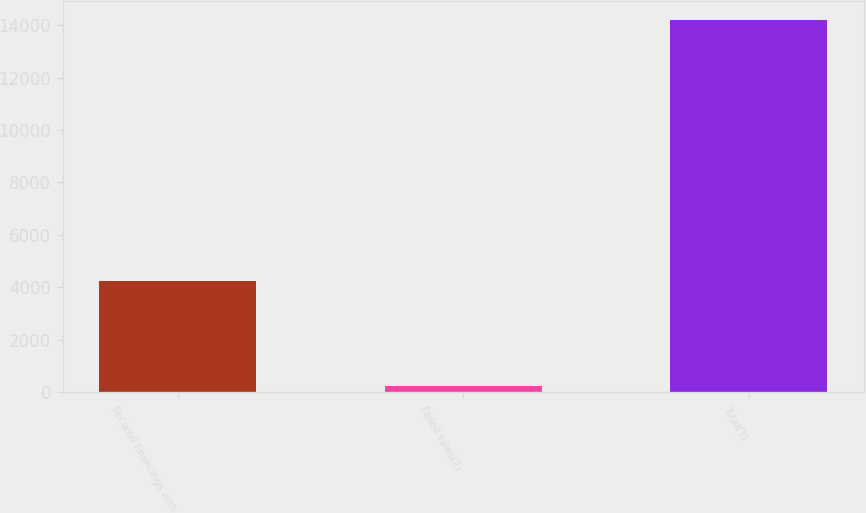Convert chart to OTSL. <chart><loc_0><loc_0><loc_500><loc_500><bar_chart><fcel>Secured financings with<fcel>Failed sales(2)<fcel>Total(3)<nl><fcel>4233<fcel>232<fcel>14215<nl></chart> 